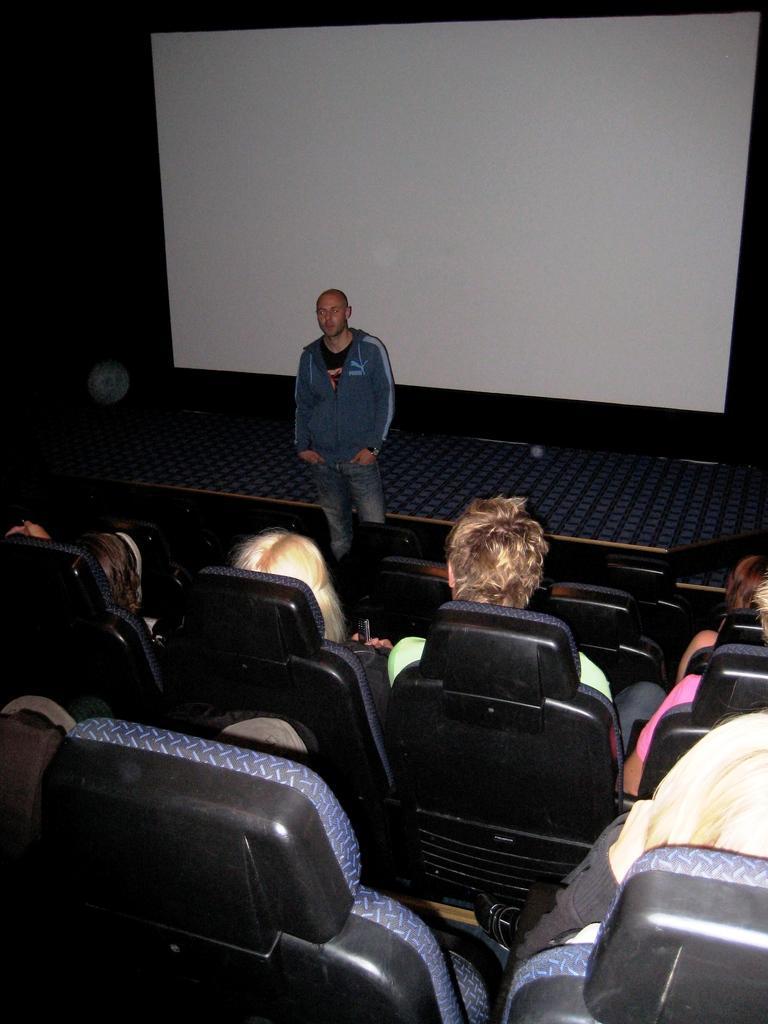In one or two sentences, can you explain what this image depicts? In this picture we can see some people are sitting on a chairs, in front one person is standing and talking, behind we can see white color board. 